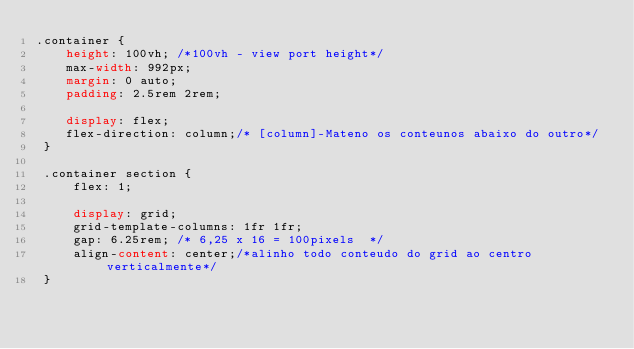<code> <loc_0><loc_0><loc_500><loc_500><_CSS_>.container {
    height: 100vh; /*100vh - view port height*/
    max-width: 992px;
    margin: 0 auto;
    padding: 2.5rem 2rem;
 
    display: flex;
    flex-direction: column;/* [column]-Mateno os conteunos abaixo do outro*/
 }

 .container section {
     flex: 1;

     display: grid;
     grid-template-columns: 1fr 1fr;
     gap: 6.25rem; /* 6,25 x 16 = 100pixels  */
     align-content: center;/*alinho todo conteudo do grid ao centro verticalmente*/
 }</code> 